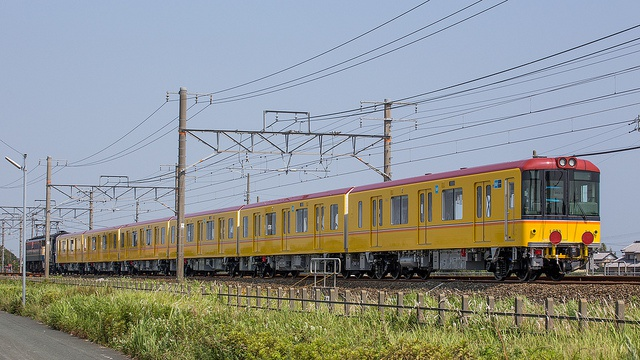Describe the objects in this image and their specific colors. I can see a train in darkgray, black, gray, and olive tones in this image. 